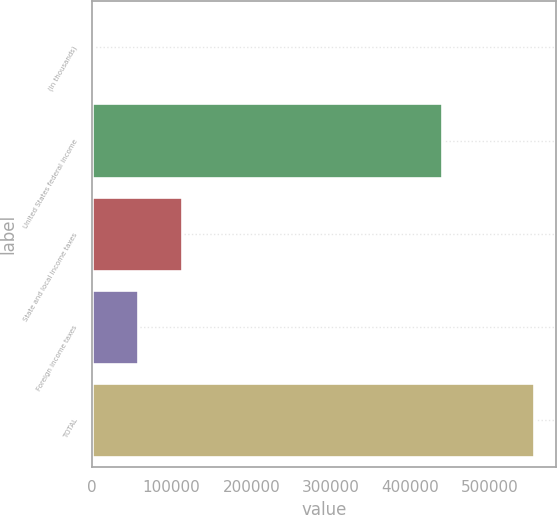Convert chart to OTSL. <chart><loc_0><loc_0><loc_500><loc_500><bar_chart><fcel>(In thousands)<fcel>United States federal income<fcel>State and local income taxes<fcel>Foreign income taxes<fcel>TOTAL<nl><fcel>2013<fcel>439667<fcel>112616<fcel>57314.5<fcel>555028<nl></chart> 